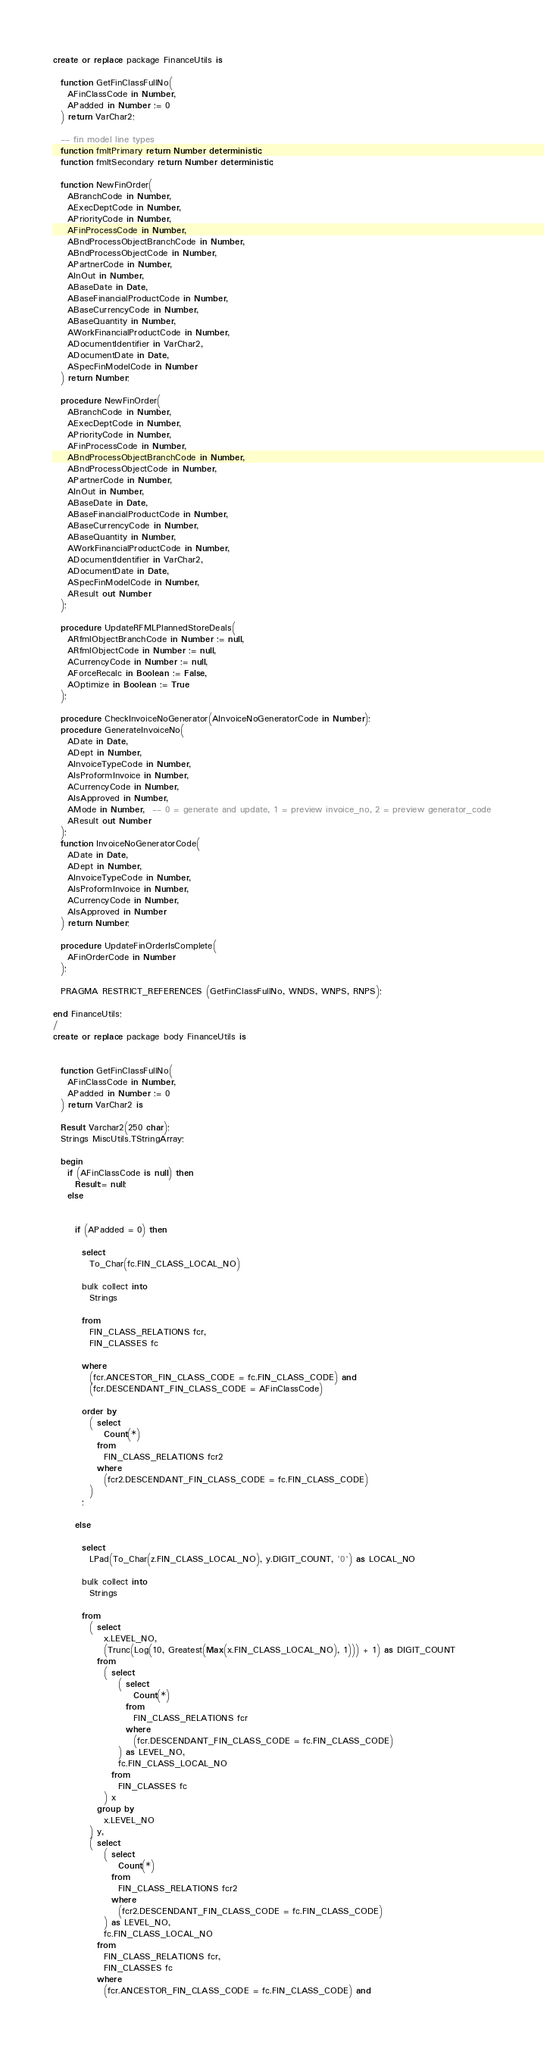Convert code to text. <code><loc_0><loc_0><loc_500><loc_500><_SQL_>create or replace package FinanceUtils is  

  function GetFinClassFullNo(
    AFinClassCode in Number,
    APadded in Number := 0
  ) return VarChar2;

  -- fin model line types
  function fmltPrimary return Number deterministic;
  function fmltSecondary return Number deterministic;

  function NewFinOrder(
    ABranchCode in Number,
    AExecDeptCode in Number,
    APriorityCode in Number,
    AFinProcessCode in Number,
    ABndProcessObjectBranchCode in Number,
    ABndProcessObjectCode in Number,
    APartnerCode in Number,
    AInOut in Number,
    ABaseDate in Date,
    ABaseFinancialProductCode in Number,
    ABaseCurrencyCode in Number,
    ABaseQuantity in Number,
    AWorkFinancialProductCode in Number,
    ADocumentIdentifier in VarChar2,
    ADocumentDate in Date,
    ASpecFinModelCode in Number
  ) return Number;

  procedure NewFinOrder(
    ABranchCode in Number,
    AExecDeptCode in Number,
    APriorityCode in Number,
    AFinProcessCode in Number,
    ABndProcessObjectBranchCode in Number,
    ABndProcessObjectCode in Number,
    APartnerCode in Number,
    AInOut in Number,
    ABaseDate in Date,
    ABaseFinancialProductCode in Number,
    ABaseCurrencyCode in Number,
    ABaseQuantity in Number,
    AWorkFinancialProductCode in Number,
    ADocumentIdentifier in VarChar2,
    ADocumentDate in Date,
    ASpecFinModelCode in Number,
    AResult out Number
  );

  procedure UpdateRFMLPlannedStoreDeals(
    ARfmlObjectBranchCode in Number := null,
    ARfmlObjectCode in Number := null,
    ACurrencyCode in Number := null,
    AForceRecalc in Boolean := False,
    AOptimize in Boolean := True
  );

  procedure CheckInvoiceNoGenerator(AInvoiceNoGeneratorCode in Number);
  procedure GenerateInvoiceNo(
    ADate in Date,
    ADept in Number,
    AInvoiceTypeCode in Number,
    AIsProformInvoice in Number,
    ACurrencyCode in Number,
    AIsApproved in Number,
    AMode in Number,  -- 0 = generate and update, 1 = preview invoice_no, 2 = preview generator_code
    AResult out Number
  );
  function InvoiceNoGeneratorCode(
    ADate in Date,
    ADept in Number,
    AInvoiceTypeCode in Number,
    AIsProformInvoice in Number,
    ACurrencyCode in Number,
    AIsApproved in Number
  ) return Number;
  
  procedure UpdateFinOrderIsComplete(
    AFinOrderCode in Number
  );

  PRAGMA RESTRICT_REFERENCES (GetFinClassFullNo, WNDS, WNPS, RNPS);
  
end FinanceUtils;
/
create or replace package body FinanceUtils is
  

  function GetFinClassFullNo(
    AFinClassCode in Number,
    APadded in Number := 0
  ) return VarChar2 is

  Result Varchar2(250 char);
  Strings MiscUtils.TStringArray;

  begin
    if (AFinClassCode is null) then
      Result:= null;
    else

    
      if (APadded = 0) then
      
        select
          To_Char(fc.FIN_CLASS_LOCAL_NO)
  
        bulk collect into
          Strings
  
        from
          FIN_CLASS_RELATIONS fcr,
          FIN_CLASSES fc

        where
          (fcr.ANCESTOR_FIN_CLASS_CODE = fc.FIN_CLASS_CODE) and
          (fcr.DESCENDANT_FIN_CLASS_CODE = AFinClassCode)
          
        order by
          ( select
              Count(*)
            from
              FIN_CLASS_RELATIONS fcr2
            where
              (fcr2.DESCENDANT_FIN_CLASS_CODE = fc.FIN_CLASS_CODE)
          )
        ;
  
      else    
  
        select
          LPad(To_Char(z.FIN_CLASS_LOCAL_NO), y.DIGIT_COUNT, '0') as LOCAL_NO
  
        bulk collect into
          Strings
  
        from
          ( select
              x.LEVEL_NO,
              (Trunc(Log(10, Greatest(Max(x.FIN_CLASS_LOCAL_NO), 1))) + 1) as DIGIT_COUNT
            from
              ( select
                  ( select
                      Count(*)
                    from
                      FIN_CLASS_RELATIONS fcr
                    where
                      (fcr.DESCENDANT_FIN_CLASS_CODE = fc.FIN_CLASS_CODE)
                  ) as LEVEL_NO,
                  fc.FIN_CLASS_LOCAL_NO
                from
                  FIN_CLASSES fc
              ) x
            group by
              x.LEVEL_NO
          ) y,
          ( select
              ( select
                  Count(*)
                from
                  FIN_CLASS_RELATIONS fcr2
                where
                  (fcr2.DESCENDANT_FIN_CLASS_CODE = fc.FIN_CLASS_CODE)
              ) as LEVEL_NO,
              fc.FIN_CLASS_LOCAL_NO
            from
              FIN_CLASS_RELATIONS fcr,
              FIN_CLASSES fc
            where
              (fcr.ANCESTOR_FIN_CLASS_CODE = fc.FIN_CLASS_CODE) and</code> 